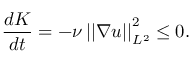Convert formula to latex. <formula><loc_0><loc_0><loc_500><loc_500>\frac { d K } { d t } = - \nu \left | \left | \nabla u \right | \right | _ { L ^ { 2 } } ^ { 2 } \leq 0 .</formula> 